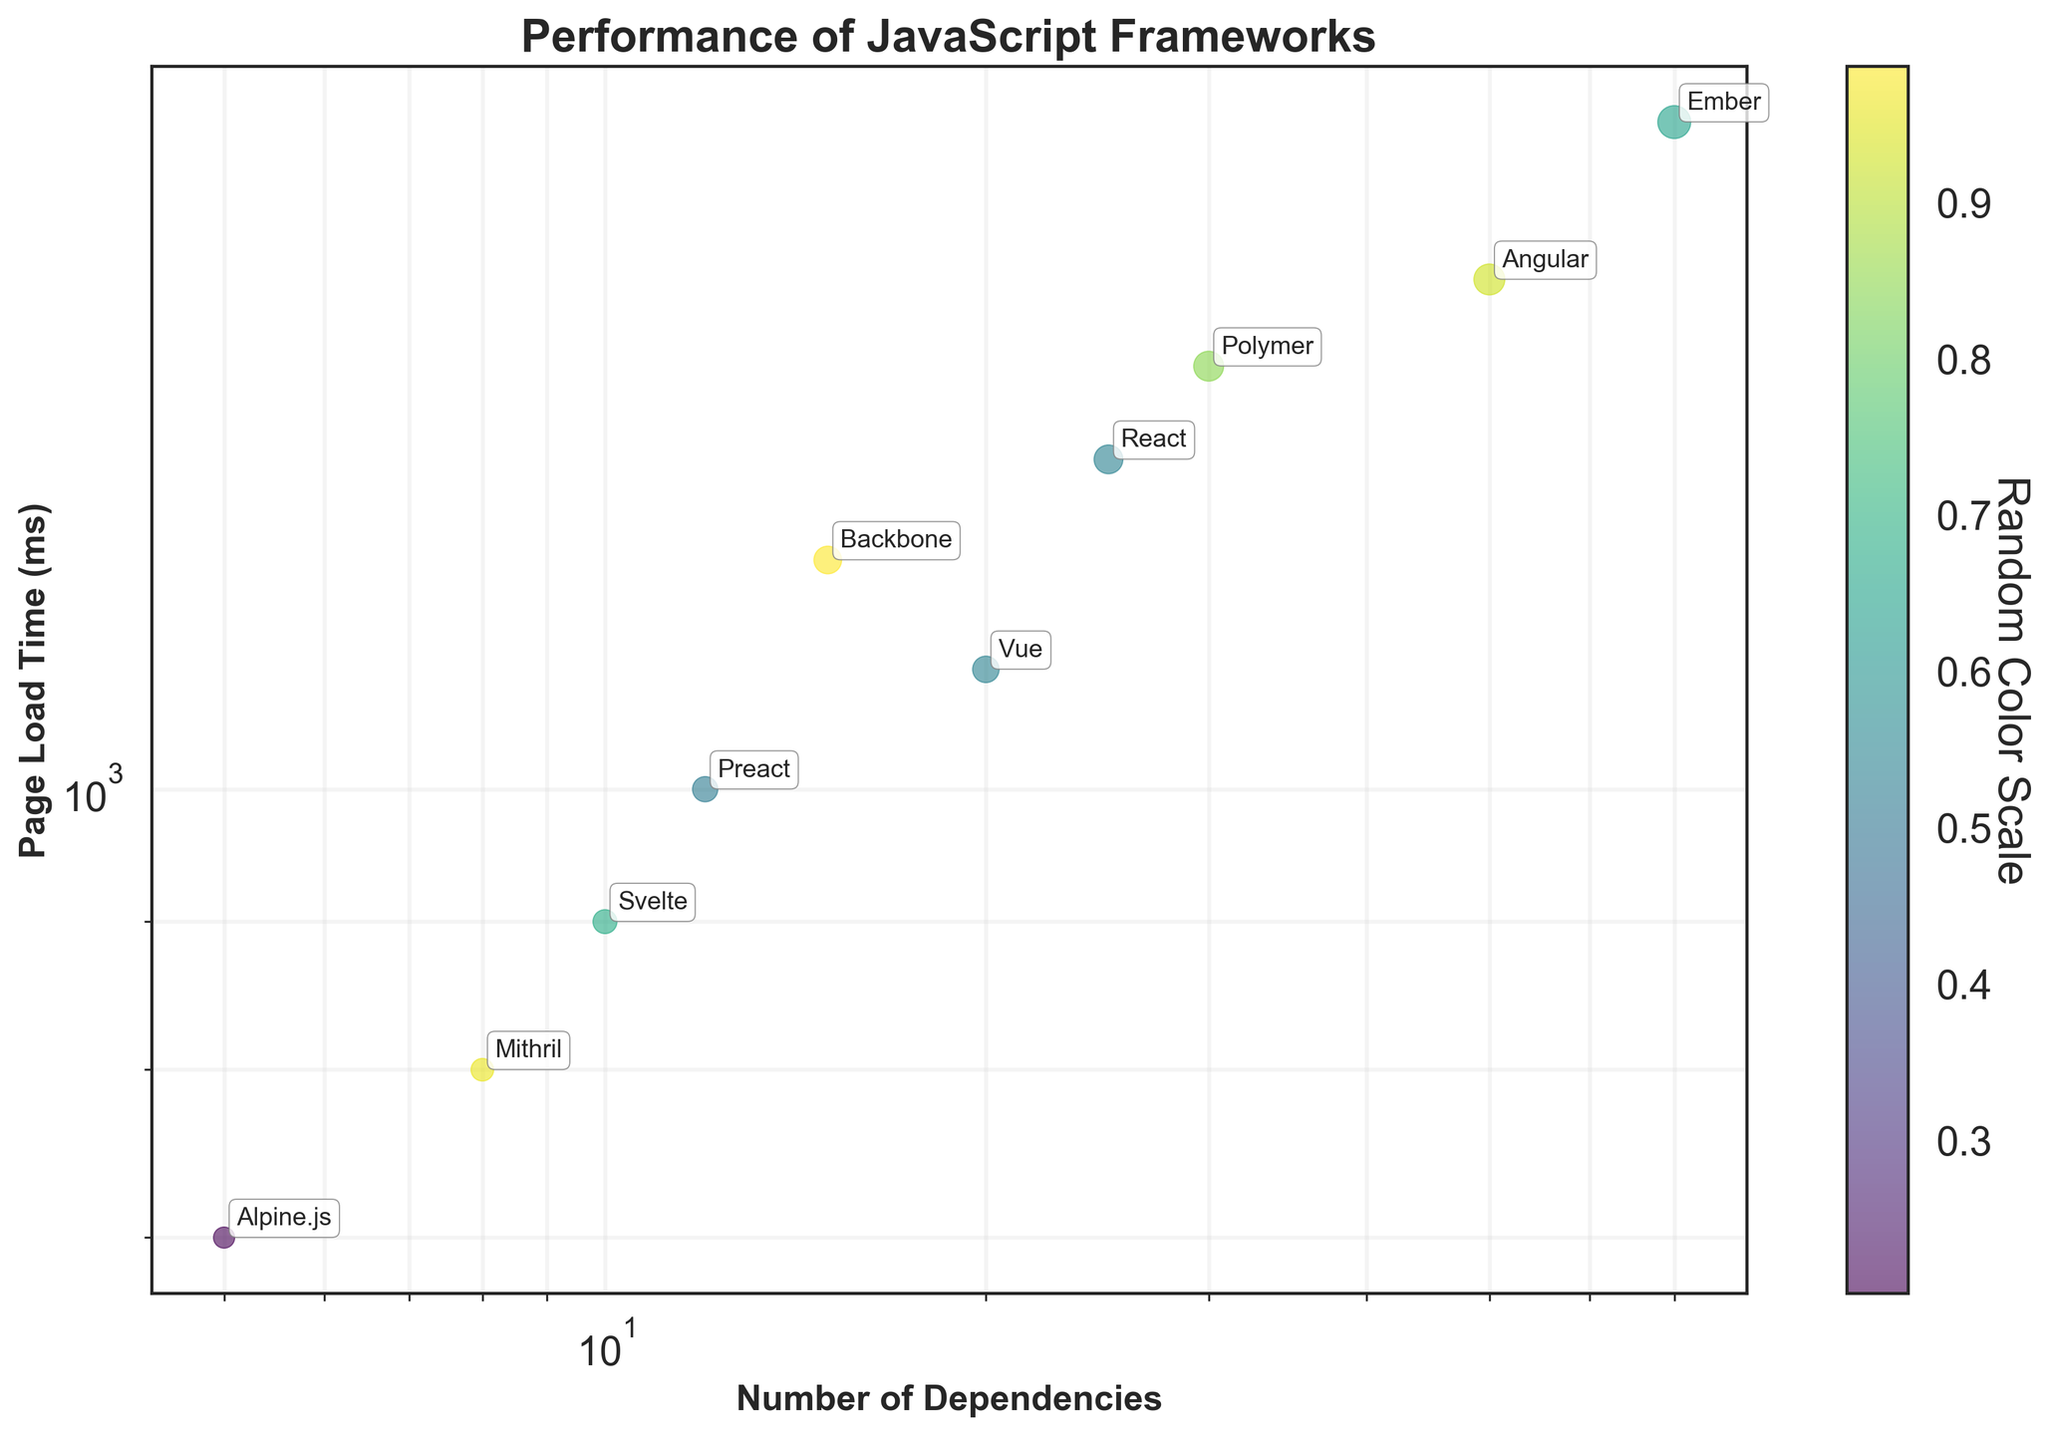What is the title of the scatter plot? The title of the scatter plot is displayed at the top. It is "Performance of JavaScript Frameworks".
Answer: Performance of JavaScript Frameworks How many JavaScript frameworks are represented in the scatter plot? Count the number of unique data points (annotated names) in the scatter plot.
Answer: 10 Which JavaScript framework has the shortest page load time? Identify the data point with the smallest y-value, which represents the page load time on a logarithmic scale.
Answer: Alpine.js Which JavaScript framework has the highest number of dependencies? Look for the data point with the largest x-value, which represents the number of dependencies on a logarithmic scale.
Answer: Ember What is the page load time of React? Locate the data point labeled "React" and read off the y-value (page load time) associated with it.
Answer: 1300 ms Which framework has a lower page load time: Vue or Angular? Compare the y-values (page load times) of the data points labeled "Vue" and "Angular". Vue's y-value is 1100 ms and Angular's is 1500 ms, so Vue has a lower page load time.
Answer: Vue Compare React and Backbone in terms of page load time and number of dependencies. Which is better in both categories? Check the page load times (y-values) and number of dependencies (x-values) for both React and Backbone. React: 1300 ms, 25 dependencies. Backbone: 1200 ms, 15 dependencies. Backbone is better in both categories.
Answer: Backbone What is the relationship between the number of dependencies and page load time in the scatter plot? Observe the general trend of the data points. As the number of dependencies increases (x-axis), the page load time (y-axis) generally increases as well, indicating a positive correlation.
Answer: Positive correlation What is the average page load time of the frameworks displayed? Sum the page load times of all frameworks and divide by the number of frameworks: (1300 + 1500 + 1100 + 900 + 1700 + 1200 + 1000 + 800 + 700 + 1400) / 10 = 11600 / 10 = 1160 ms.
Answer: 1160 ms What is the median number of dependencies for the frameworks? List the dependencies in ascending order: 5, 8, 10, 12, 15, 20, 25, 30, 50, 70. The median is the average of the middle two numbers: (15 + 20) / 2 = 17.5.
Answer: 17.5 